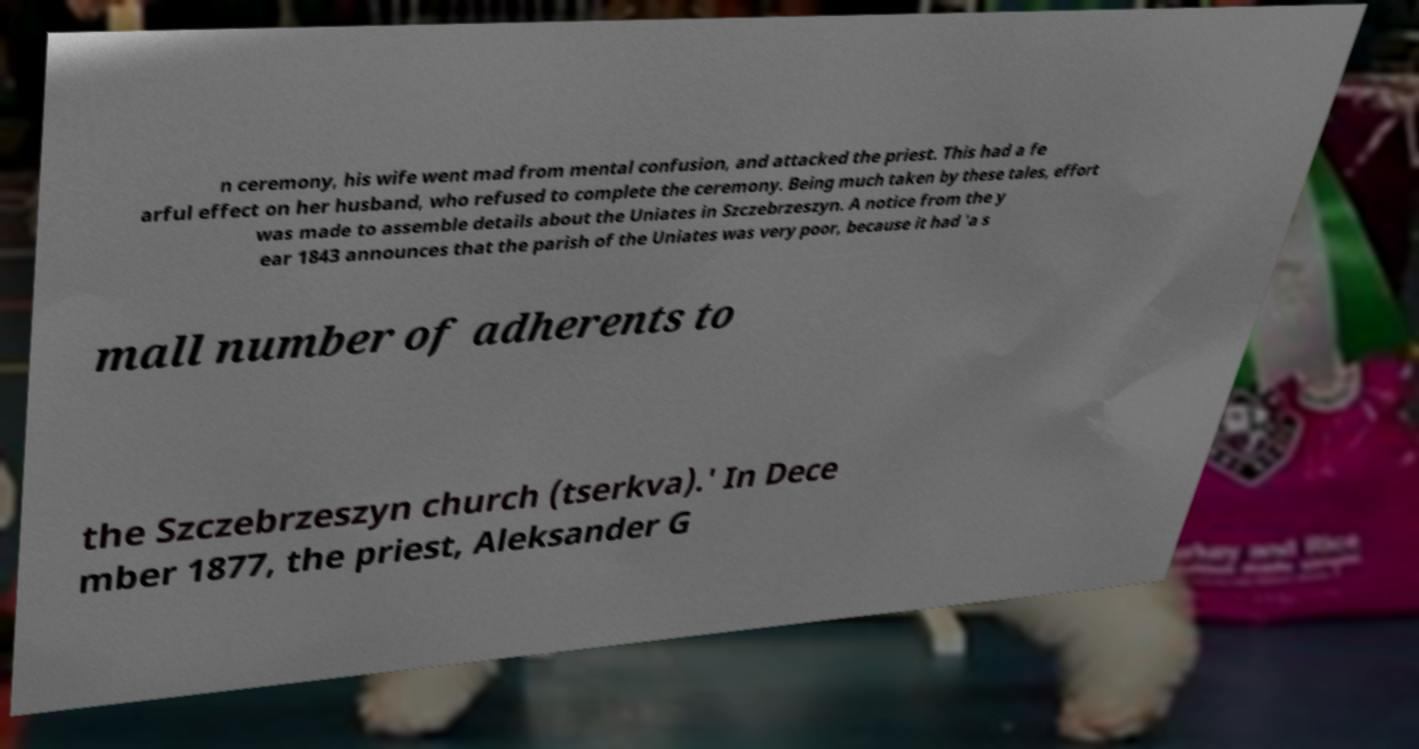Please read and relay the text visible in this image. What does it say? n ceremony, his wife went mad from mental confusion, and attacked the priest. This had a fe arful effect on her husband, who refused to complete the ceremony. Being much taken by these tales, effort was made to assemble details about the Uniates in Szczebrzeszyn. A notice from the y ear 1843 announces that the parish of the Uniates was very poor, because it had 'a s mall number of adherents to the Szczebrzeszyn church (tserkva).' In Dece mber 1877, the priest, Aleksander G 